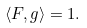Convert formula to latex. <formula><loc_0><loc_0><loc_500><loc_500>\langle F , g \rangle = 1 .</formula> 